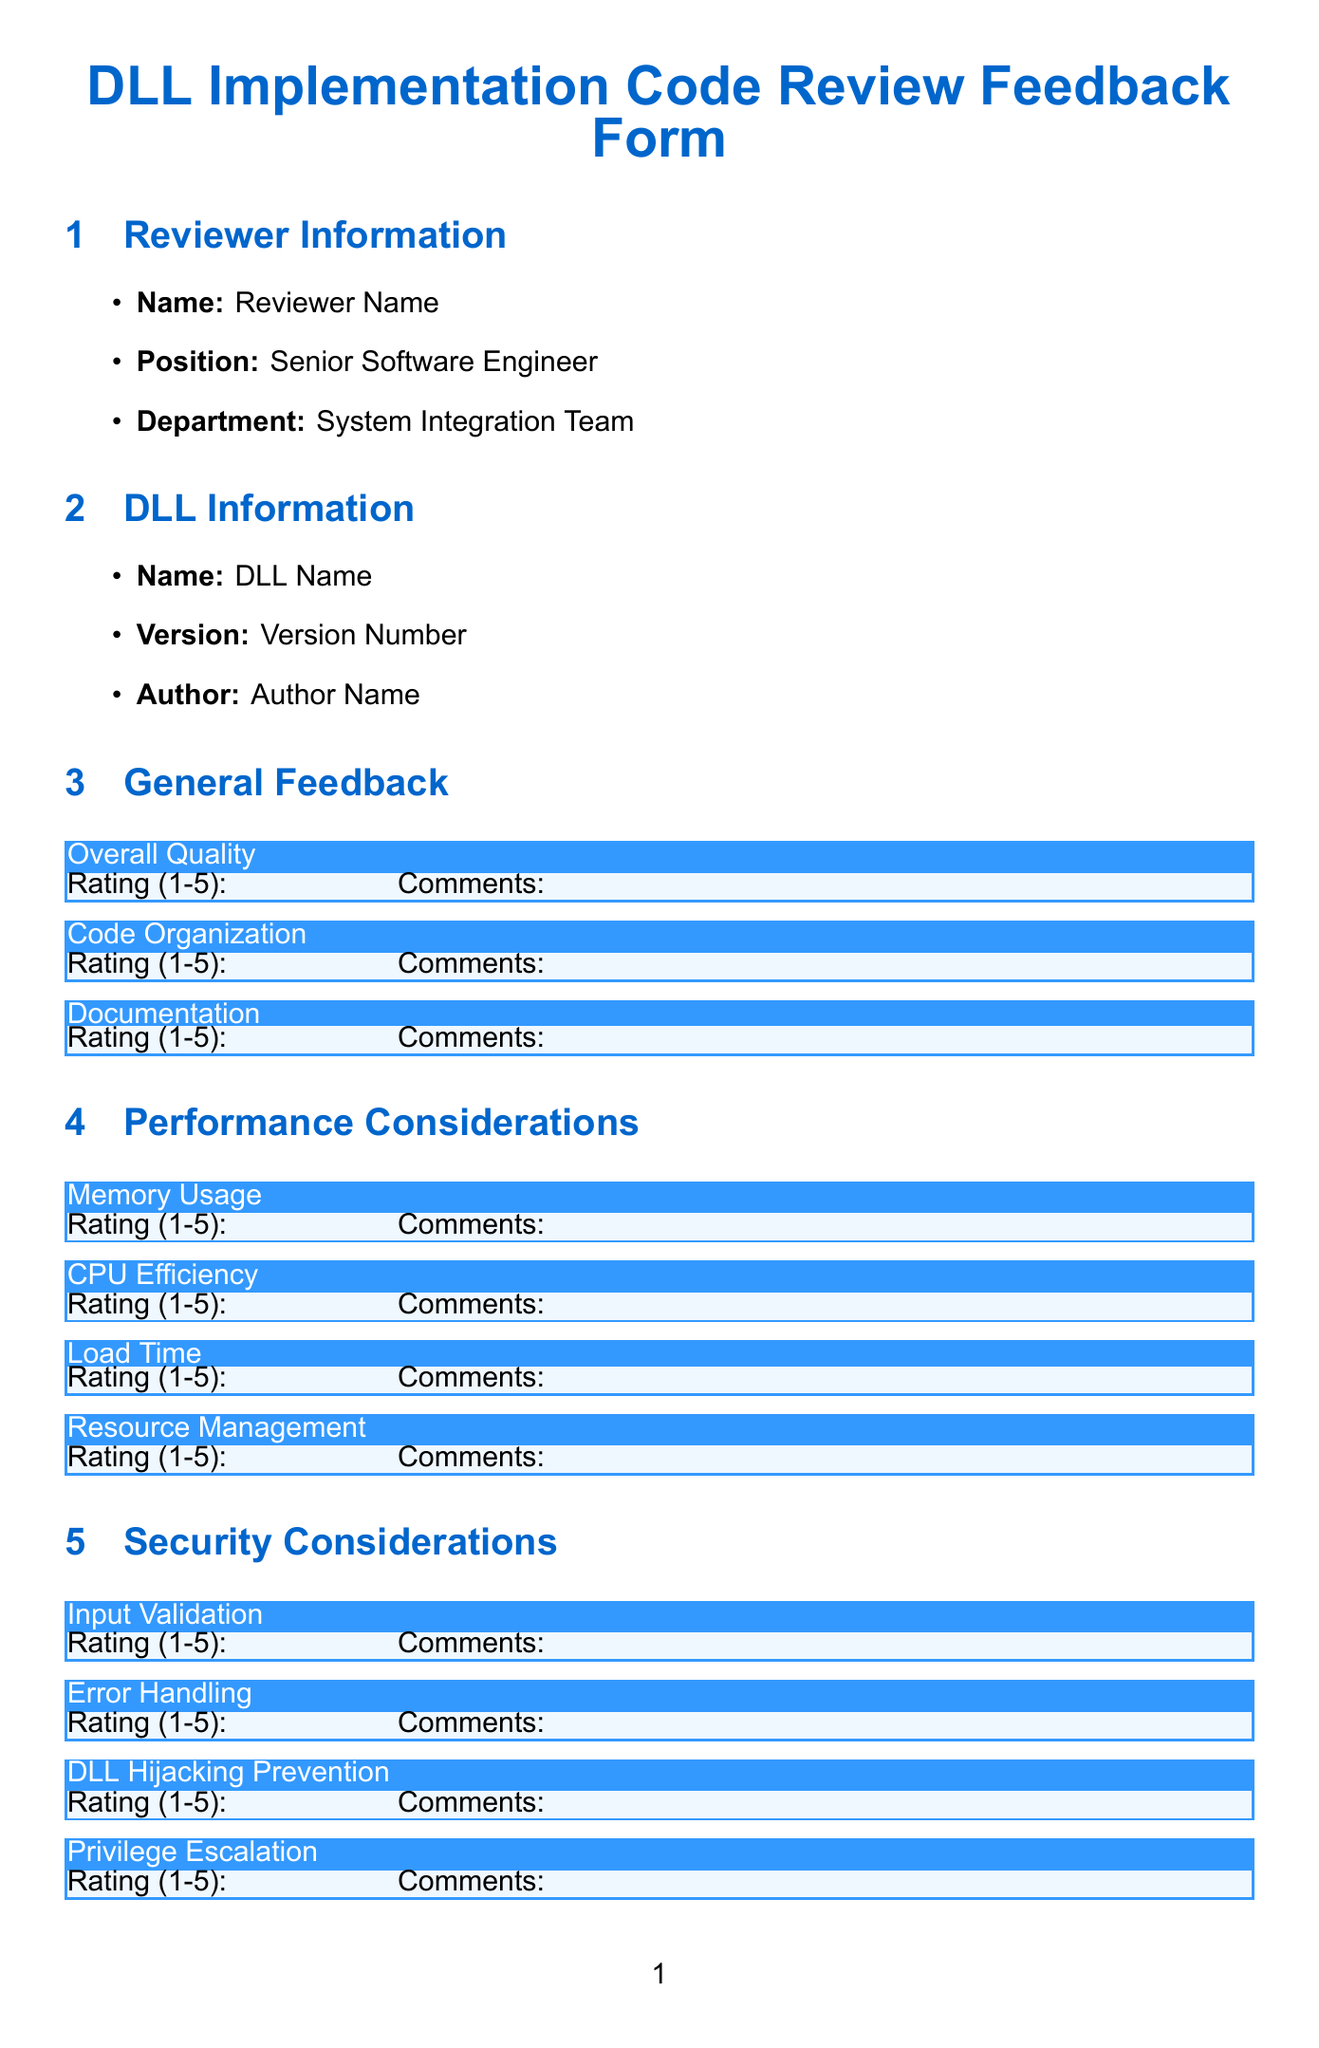What is the title of the form? The title can be found at the top of the document, indicating the purpose of the form.
Answer: DLL Implementation Code Review Feedback Form What is the name of the reviewer? This information is located under the Reviewer Information section of the document.
Answer: Reviewer Name What rating scale is used for feedback? The document mentions a specific scale for ratings provided throughout the feedback sections.
Answer: 1-5 scale What tools were used for the review? The Tools Used section lists the software tools utilized during the code review process.
Answer: Visual Studio 2022, Dependency Walker, Process Monitor, IDA Pro, Valgrind What is the feedback rating for CPU Efficiency? This section in the Performance Considerations requires the reviewer to provide a rating which is to be filled in.
Answer: Rating (1-5): What comments are suggested for input validation? This is a specified area in the Security Considerations that requires feedback.
Answer: Comments: What is included in the Additional Notes section? The Additional Notes section allows reviewers to add any relevant information they find necessary.
Answer: Any other relevant information or concerns What does the reviewer need to provide below the Recommendations section? This part of the document addresses the required signatures and date completion from the reviewer.
Answer: Reviewer's electronic signature What date format is mentioned for the completion date? The structure indicates how the completion date should be filled out in the document.
Answer: YYYY-MM-DD 